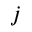Convert formula to latex. <formula><loc_0><loc_0><loc_500><loc_500>j</formula> 